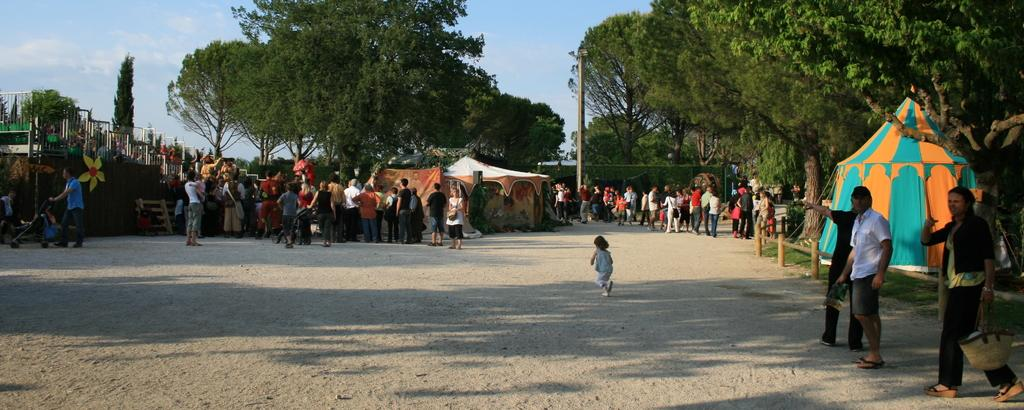What can be seen in the image? There are people standing in the image. What is visible in the background of the image? There are tents, railing, trees with green color, and the sky in the background of the image. Can you describe the sky in the image? The sky is visible in the image, with white and blue colors. What type of soda is being served at the baby's birthday party in the image? There is no baby, birthday party, or soda present in the image. 